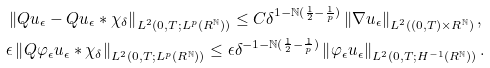<formula> <loc_0><loc_0><loc_500><loc_500>& \left \| Q u _ { \epsilon } - Q u _ { \epsilon } * \chi _ { \delta } \right \| _ { L ^ { 2 } ( 0 , T ; L ^ { p } ( R ^ { \mathbb { N } } ) ) } \leq C \delta ^ { 1 - \mathbb { N } ( \frac { 1 } { 2 } - \frac { 1 } { p } ) } \left \| \nabla u _ { \epsilon } \right \| _ { L ^ { 2 } ( ( 0 , T ) \times R ^ { \mathbb { N } } ) } , \\ & \epsilon \left \| Q \varphi _ { \epsilon } u _ { \epsilon } * \chi _ { \delta } \right \| _ { L ^ { 2 } ( 0 , T ; L ^ { p } ( R ^ { \mathbb { N } } ) ) } \leq \epsilon \delta ^ { - 1 - \mathbb { N } ( \frac { 1 } { 2 } - \frac { 1 } { p } ) } \left \| \varphi _ { \epsilon } u _ { \epsilon } \right \| _ { L ^ { 2 } ( 0 , T ; H ^ { - 1 } ( R ^ { \mathbb { N } } ) ) } .</formula> 